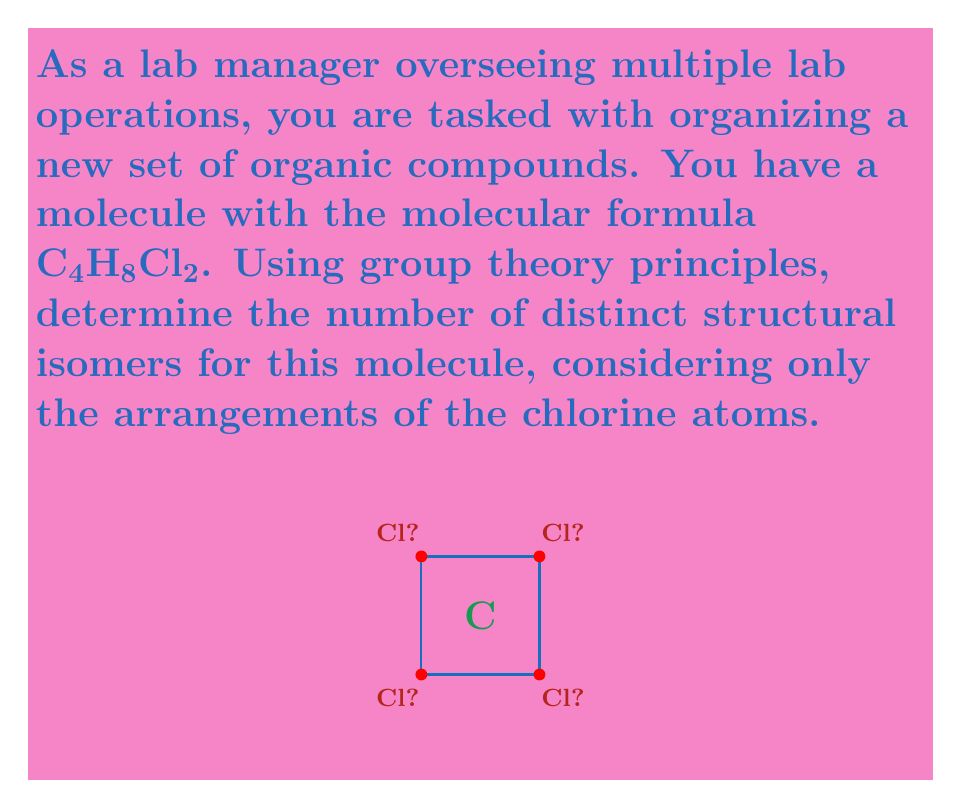What is the answer to this math problem? To solve this problem using group theory principles, we'll follow these steps:

1) First, we need to identify the symmetry group of the molecule. The base structure is a square (representing the carbon atoms), which has the symmetry group $D_{4h}$.

2) The order of $D_{4h}$ is 16, which includes rotations, reflections, and inversions.

3) We need to place 2 chlorine atoms on the 4 available positions. This is equivalent to coloring 2 vertices of the square.

4) The number of ways to color 2 vertices out of 4 is $\binom{4}{2} = 6$. This represents all possible arrangements without considering symmetry.

5) To account for symmetry, we use Burnside's lemma:

   $$N = \frac{1}{|G|} \sum_{g \in G} |X^g|$$

   Where $N$ is the number of distinct isomers, $|G|$ is the order of the symmetry group, and $|X^g|$ is the number of colorings fixed by each symmetry operation $g$.

6) Calculating $|X^g|$ for each symmetry operation:
   - Identity (1): Fixes all 6 colorings
   - 90° rotations (2): Fix no colorings
   - 180° rotation (1): Fixes 1 coloring
   - Reflections through diagonals (2): Fix 1 coloring each
   - Reflections through midpoints (2): Fix 2 colorings each
   - Inversion (1): Fixes 1 coloring

7) Applying Burnside's lemma:

   $$N = \frac{1}{16}(6 + 0 + 0 + 1 + 1 + 1 + 2 + 2 + 1) = \frac{14}{16} = \frac{7}{8}$$

8) Since $N$ must be an integer, we round up to the nearest whole number.
Answer: 3 distinct isomers 